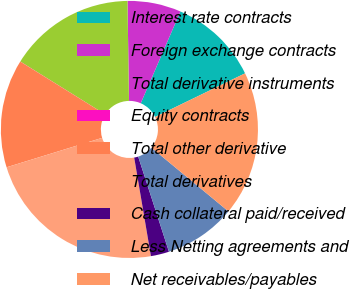Convert chart. <chart><loc_0><loc_0><loc_500><loc_500><pie_chart><fcel>Interest rate contracts<fcel>Foreign exchange contracts<fcel>Total derivative instruments<fcel>Equity contracts<fcel>Total other derivative<fcel>Total derivatives<fcel>Cash collateral paid/received<fcel>Less Netting agreements and<fcel>Net receivables/payables<nl><fcel>11.32%<fcel>6.73%<fcel>15.9%<fcel>0.01%<fcel>13.61%<fcel>22.92%<fcel>2.3%<fcel>9.02%<fcel>18.19%<nl></chart> 